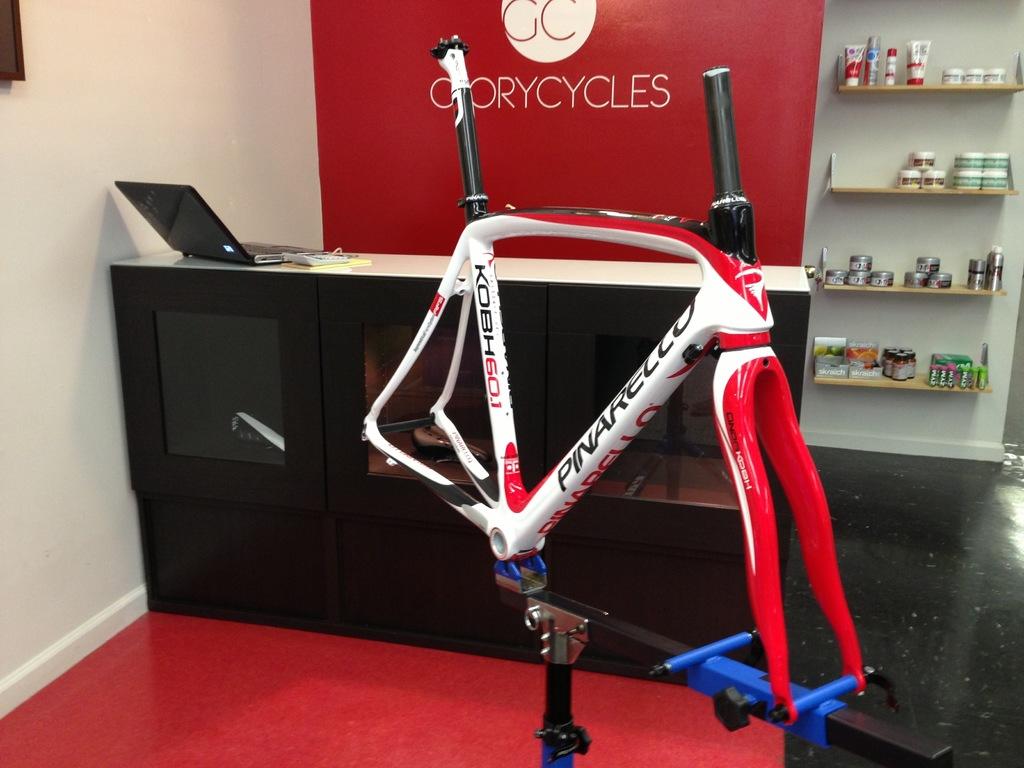What does the red sign say?
Give a very brief answer. Glorycycles. What brand is sponsoring this bicycle frame?
Offer a very short reply. Pinarello. 